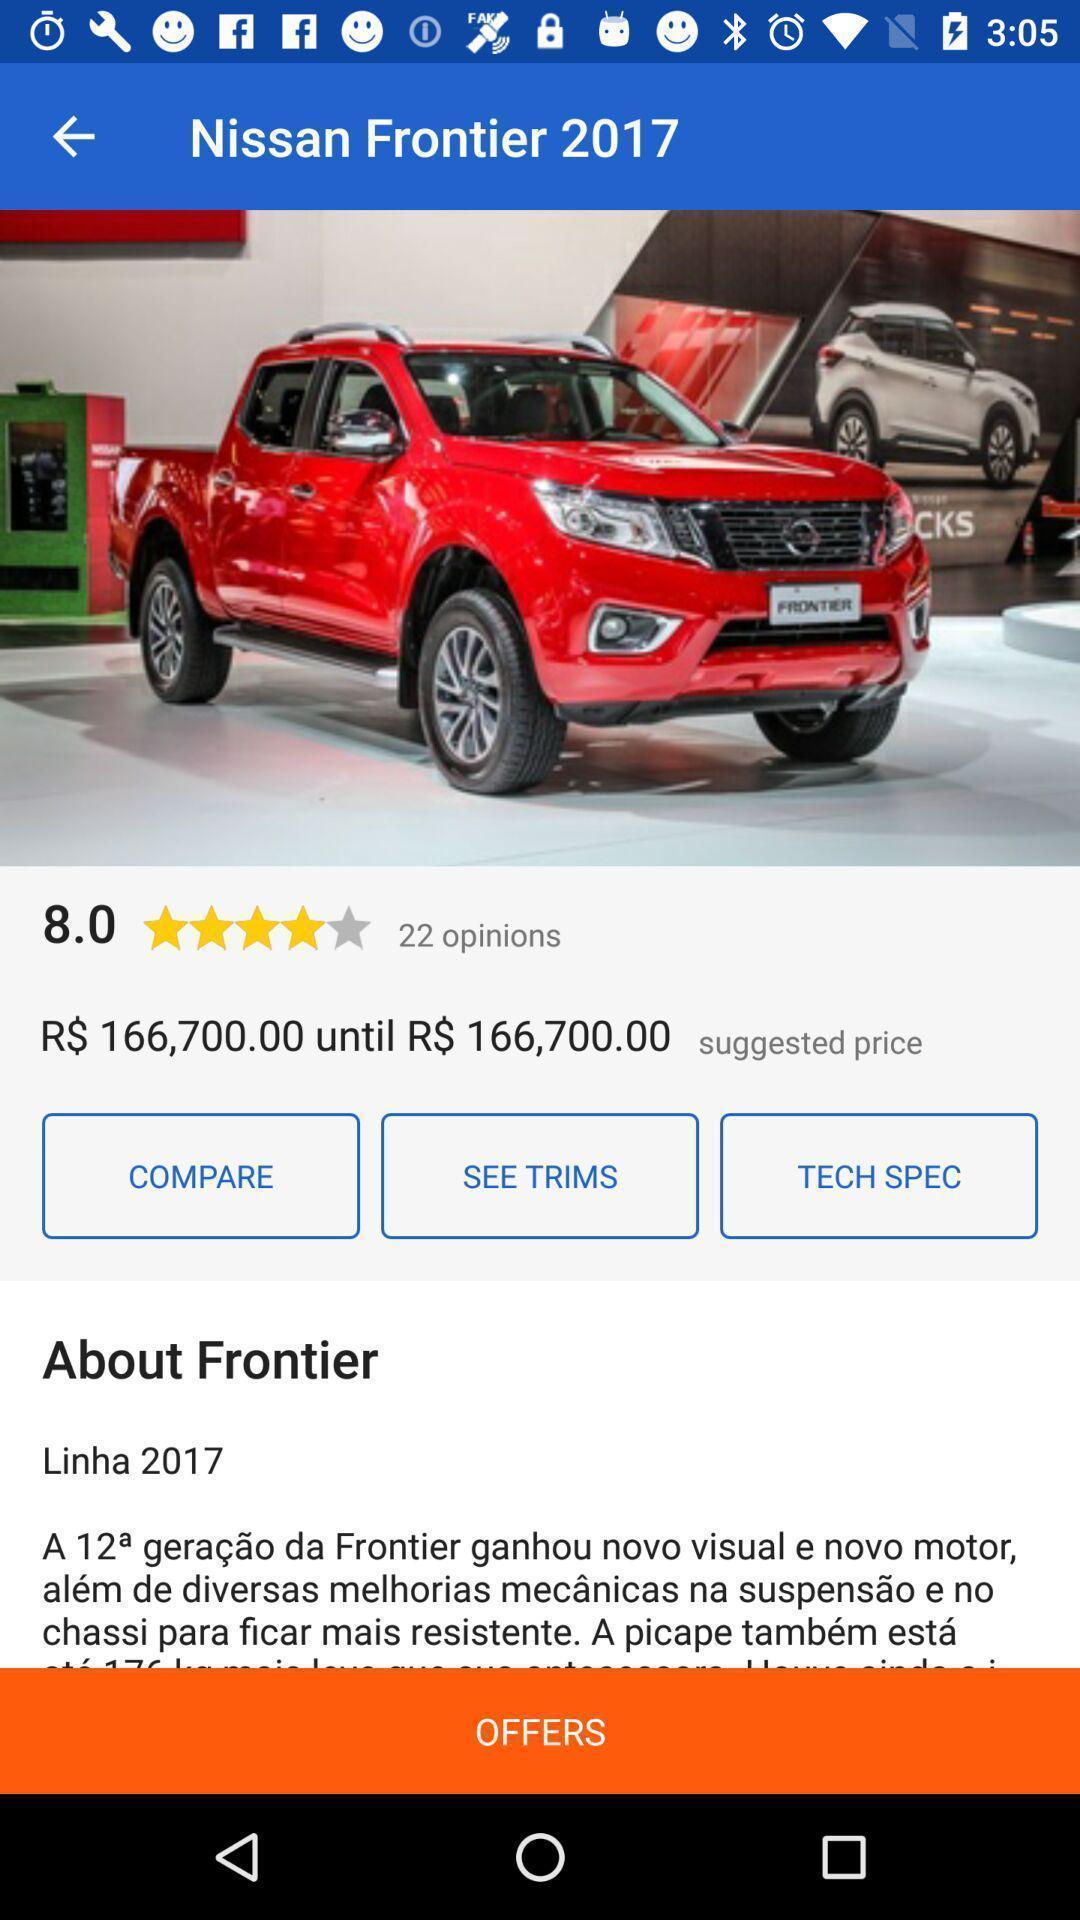Explain the elements present in this screenshot. Screen shows basic information about a car summary. 